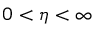<formula> <loc_0><loc_0><loc_500><loc_500>0 < \eta < \infty</formula> 